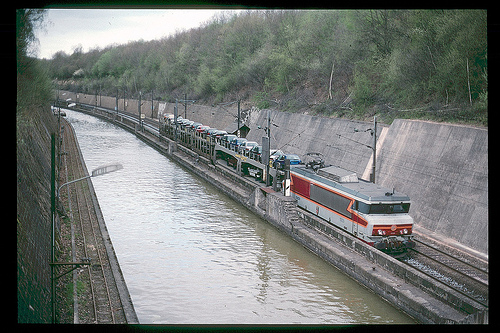<image>
Can you confirm if the train is on the water? No. The train is not positioned on the water. They may be near each other, but the train is not supported by or resting on top of the water. 